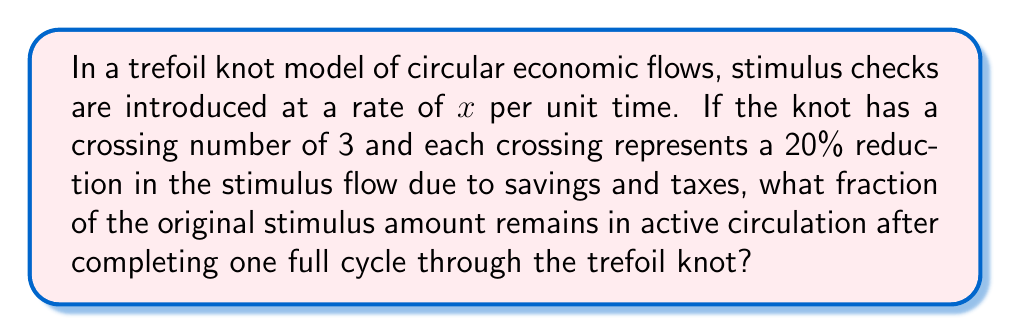Provide a solution to this math problem. To solve this problem, we need to follow these steps:

1) The trefoil knot has a crossing number of 3. This means the economic flow passes through 3 crossings in one complete cycle.

2) At each crossing, there's a 20% reduction in the flow. This means 80% of the flow continues after each crossing.

3) We can represent this mathematically as follows:
   After 1st crossing: $0.8x$
   After 2nd crossing: $0.8(0.8x) = 0.8^2x$
   After 3rd crossing: $0.8(0.8^2x) = 0.8^3x$

4) Therefore, after one complete cycle through the trefoil knot, the amount remaining in circulation is:

   $$0.8^3x = 0.512x$$

5) To express this as a fraction of the original amount:

   $$\frac{0.512x}{x} = 0.512 = \frac{512}{1000}$$

6) This fraction can be reduced by dividing both numerator and denominator by 8:

   $$\frac{512}{1000} = \frac{64}{125}$$

Thus, $\frac{64}{125}$ of the original stimulus amount remains in active circulation after one full cycle.
Answer: $\frac{64}{125}$ 